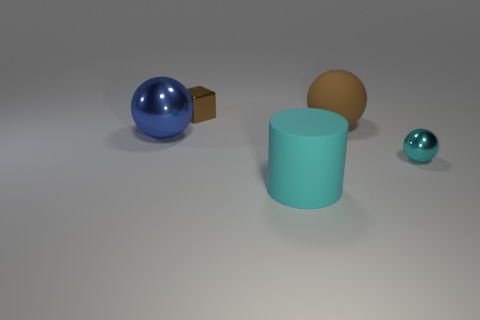Are there any blue shiny spheres?
Your answer should be compact. Yes. Are there any other things of the same color as the cube?
Give a very brief answer. Yes. What shape is the brown object that is made of the same material as the blue sphere?
Provide a succinct answer. Cube. There is a matte thing that is behind the large ball that is on the left side of the large matte object that is in front of the tiny metal ball; what color is it?
Ensure brevity in your answer.  Brown. Is the number of rubber balls that are behind the shiny block the same as the number of yellow matte blocks?
Your answer should be compact. Yes. Do the tiny ball and the thing that is in front of the small cyan sphere have the same color?
Your response must be concise. Yes. Is there a small metallic thing left of the thing in front of the shiny ball that is in front of the big blue ball?
Your answer should be very brief. Yes. Are there fewer metallic cubes to the right of the tiny brown block than brown matte balls?
Your answer should be very brief. Yes. What number of other things are the same shape as the large cyan matte object?
Offer a very short reply. 0. What number of objects are either rubber spheres that are left of the cyan sphere or big things that are behind the large metal object?
Give a very brief answer. 1. 